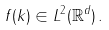<formula> <loc_0><loc_0><loc_500><loc_500>f ( k ) \in L ^ { 2 } ( \mathbb { R } ^ { d } ) \, .</formula> 